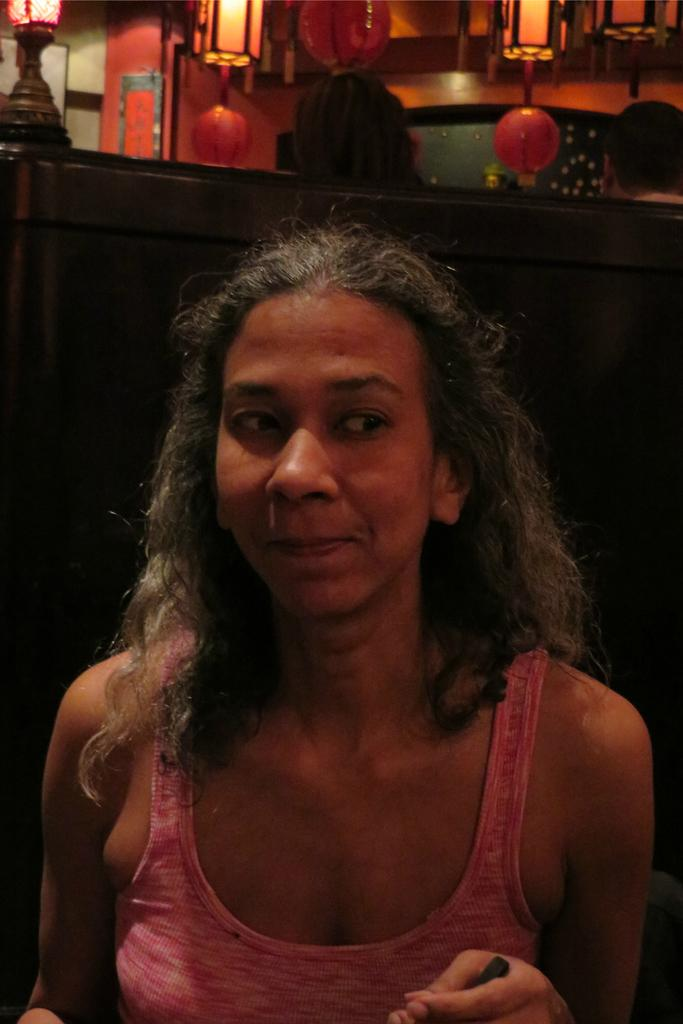Who is the main subject in the image? There is a woman in the image. Can you describe the people behind the woman? There are two persons behind the woman. What can be seen in the background of the image? There is a wall in the background of the image. What type of lighting is present in the image? Lamps and paper lanterns are hanging from the ceiling. How does the woman become an expert in the image? There is no indication in the image that the woman is becoming an expert or has any specific expertise. 